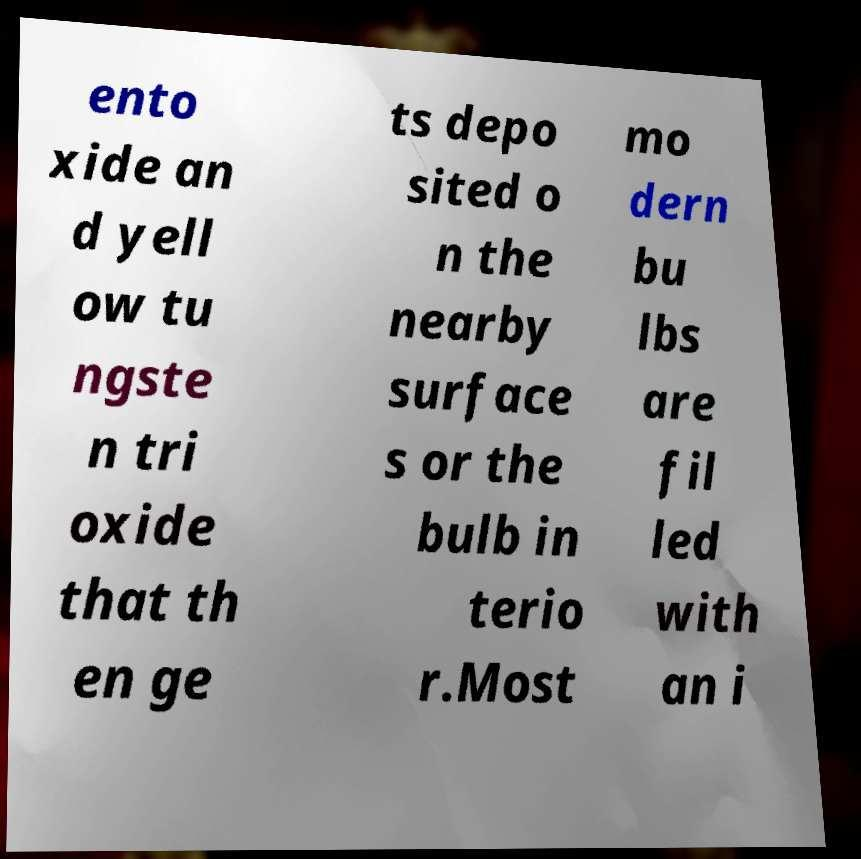Can you read and provide the text displayed in the image?This photo seems to have some interesting text. Can you extract and type it out for me? ento xide an d yell ow tu ngste n tri oxide that th en ge ts depo sited o n the nearby surface s or the bulb in terio r.Most mo dern bu lbs are fil led with an i 